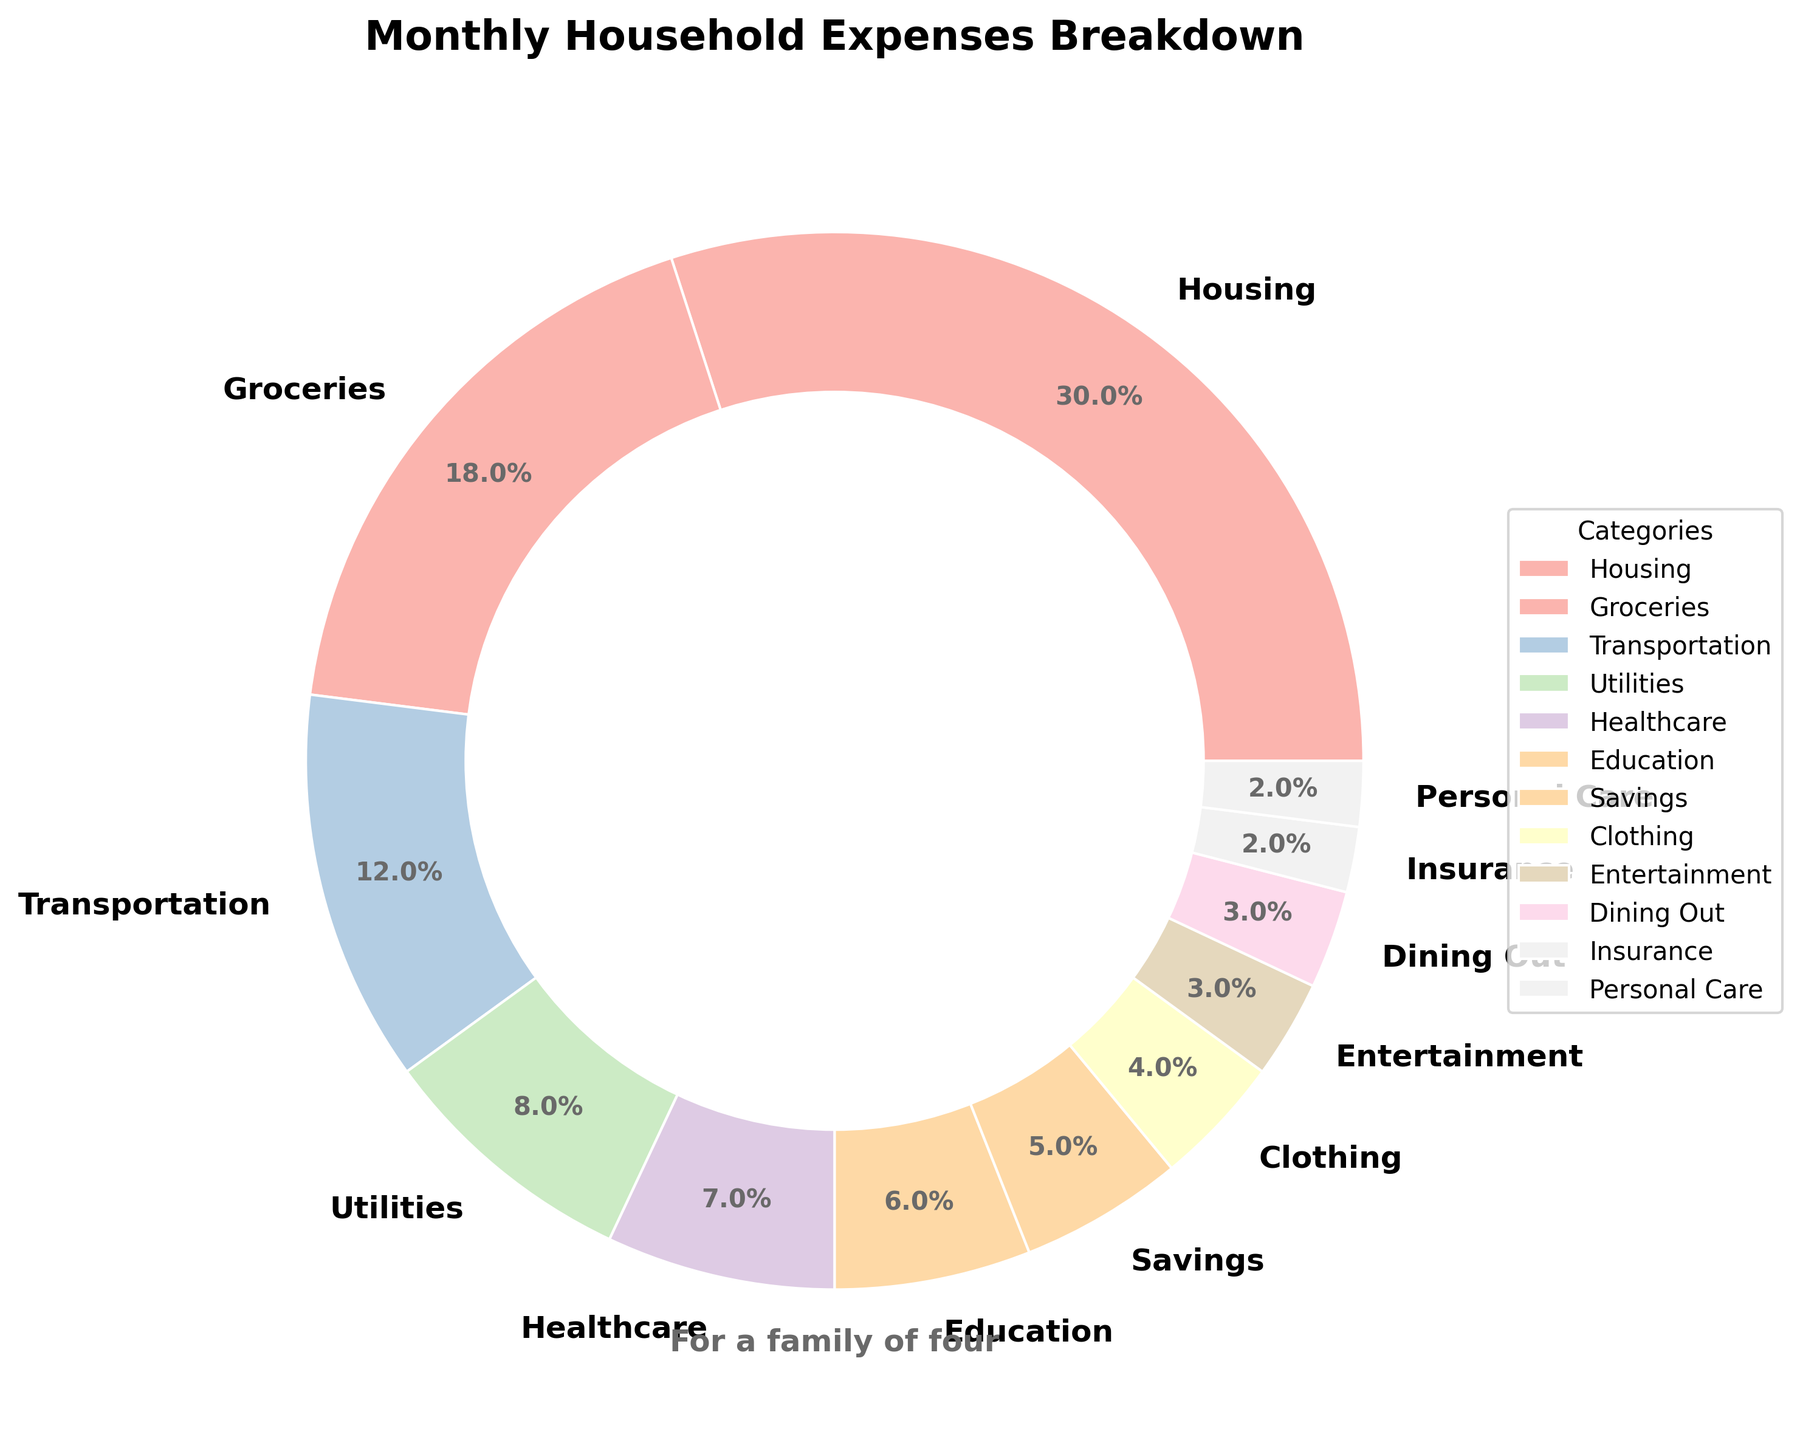What is the largest expense category? The largest expense category can be identified by finding the slice with the highest percentage. According to the chart, the largest slice corresponds to 'Housing' with 30%.
Answer: Housing Which category accounts for the least expenditure? The smallest slice, which indicates the least expenditure, is identified. 'Insurance' and 'Personal Care' both account for the smallest percentage, each at 2%.
Answer: Insurance, Personal Care What is the combined percentage of Groceries, Utilities, and Healthcare? To find the combined percentage, add the percentages of Groceries (18%), Utilities (8%), and Healthcare (7%): 18% + 8% + 7% = 33%.
Answer: 33% Which two categories together make up the largest portion of the monthly expenses? Adding the percentages of 'Housing' (30%) and 'Groceries' (18%) gives 30% + 18% = 48%, which is the highest combined percentage among all possible pairs.
Answer: Housing and Groceries Which is higher, the expenditure on Education or the expenditure on Clothing? Comparing the slices labelled 'Education' (6%) and 'Clothing' (4%), 'Education' has a higher expenditure.
Answer: Education What is the total percentage spent on non-essential items (Entertainment, Dining Out, Personal Care)? Sum the percentages for Entertainment (3%), Dining Out (3%), and Personal Care (2%): 3% + 3% + 2% = 8%.
Answer: 8% By how much does the percentage spent on Housing exceed the percentage spent on Transportation? Subtract the Transportation percentage (12%) from the Housing percentage (30%): 30% - 12% = 18%.
Answer: 18% How does the percentage spent on Healthcare compare to the percentage spent on Utilities? Comparing 'Healthcare' (7%) and 'Utilities' (8%), Utilities have a higher percentage by 1%.
Answer: Utilities is higher by 1% If the family wanted to increase their Savings to 10%, which expense category (or categories) should they reduce without changing any others? To increase Savings to 10%, an additional 5% needs to be reallocated. The top categories to consider could be reducing Housing (30%) or Groceries (18%) slightly, Transportation (12%), or a combination as needed.
Answer: Housing, Groceries, or Transportation 